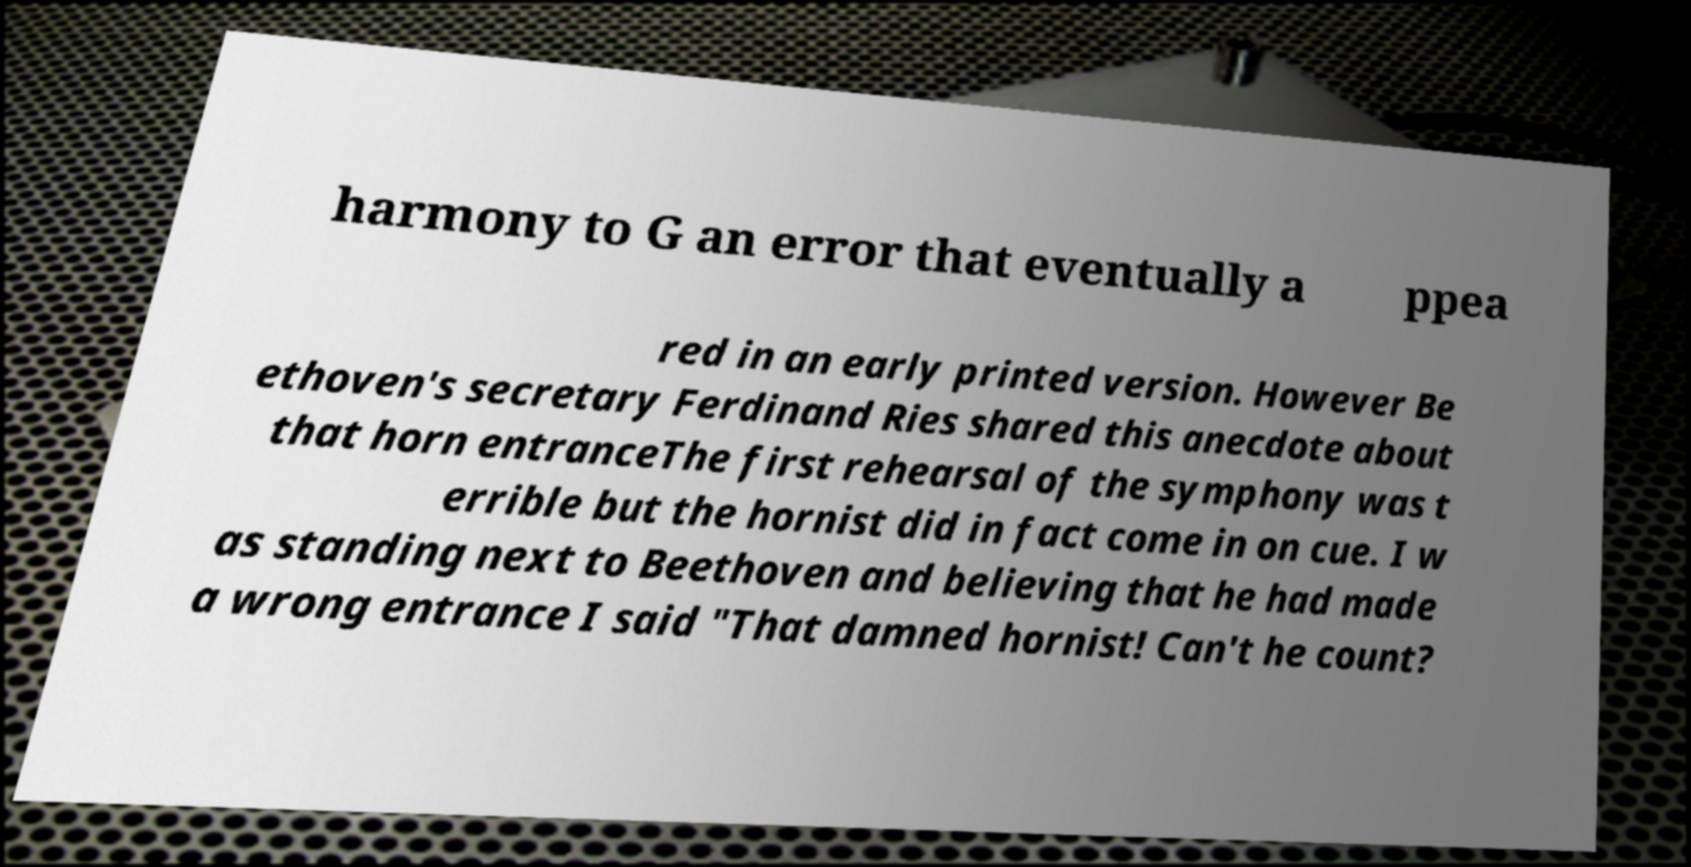There's text embedded in this image that I need extracted. Can you transcribe it verbatim? harmony to G an error that eventually a ppea red in an early printed version. However Be ethoven's secretary Ferdinand Ries shared this anecdote about that horn entranceThe first rehearsal of the symphony was t errible but the hornist did in fact come in on cue. I w as standing next to Beethoven and believing that he had made a wrong entrance I said "That damned hornist! Can't he count? 